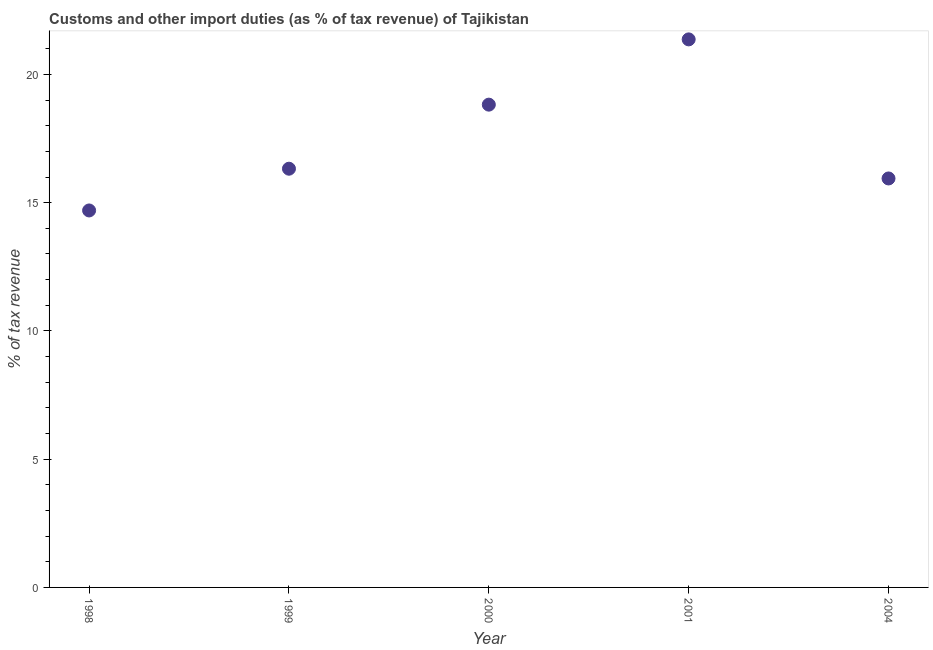What is the customs and other import duties in 2000?
Your answer should be compact. 18.82. Across all years, what is the maximum customs and other import duties?
Provide a short and direct response. 21.37. Across all years, what is the minimum customs and other import duties?
Your answer should be very brief. 14.7. In which year was the customs and other import duties maximum?
Your answer should be very brief. 2001. What is the sum of the customs and other import duties?
Your answer should be compact. 87.15. What is the difference between the customs and other import duties in 1999 and 2004?
Make the answer very short. 0.38. What is the average customs and other import duties per year?
Your answer should be very brief. 17.43. What is the median customs and other import duties?
Keep it short and to the point. 16.32. Do a majority of the years between 2001 and 2004 (inclusive) have customs and other import duties greater than 19 %?
Offer a very short reply. No. What is the ratio of the customs and other import duties in 1998 to that in 1999?
Offer a very short reply. 0.9. What is the difference between the highest and the second highest customs and other import duties?
Keep it short and to the point. 2.54. What is the difference between the highest and the lowest customs and other import duties?
Give a very brief answer. 6.67. How many dotlines are there?
Provide a short and direct response. 1. How many years are there in the graph?
Your answer should be compact. 5. Are the values on the major ticks of Y-axis written in scientific E-notation?
Keep it short and to the point. No. Does the graph contain grids?
Ensure brevity in your answer.  No. What is the title of the graph?
Your answer should be very brief. Customs and other import duties (as % of tax revenue) of Tajikistan. What is the label or title of the X-axis?
Offer a terse response. Year. What is the label or title of the Y-axis?
Give a very brief answer. % of tax revenue. What is the % of tax revenue in 1998?
Your response must be concise. 14.7. What is the % of tax revenue in 1999?
Give a very brief answer. 16.32. What is the % of tax revenue in 2000?
Offer a terse response. 18.82. What is the % of tax revenue in 2001?
Provide a short and direct response. 21.37. What is the % of tax revenue in 2004?
Offer a terse response. 15.94. What is the difference between the % of tax revenue in 1998 and 1999?
Make the answer very short. -1.63. What is the difference between the % of tax revenue in 1998 and 2000?
Your answer should be very brief. -4.13. What is the difference between the % of tax revenue in 1998 and 2001?
Provide a succinct answer. -6.67. What is the difference between the % of tax revenue in 1998 and 2004?
Make the answer very short. -1.25. What is the difference between the % of tax revenue in 1999 and 2000?
Your answer should be compact. -2.5. What is the difference between the % of tax revenue in 1999 and 2001?
Make the answer very short. -5.04. What is the difference between the % of tax revenue in 1999 and 2004?
Offer a very short reply. 0.38. What is the difference between the % of tax revenue in 2000 and 2001?
Keep it short and to the point. -2.54. What is the difference between the % of tax revenue in 2000 and 2004?
Your answer should be very brief. 2.88. What is the difference between the % of tax revenue in 2001 and 2004?
Ensure brevity in your answer.  5.42. What is the ratio of the % of tax revenue in 1998 to that in 2000?
Give a very brief answer. 0.78. What is the ratio of the % of tax revenue in 1998 to that in 2001?
Offer a terse response. 0.69. What is the ratio of the % of tax revenue in 1998 to that in 2004?
Your answer should be very brief. 0.92. What is the ratio of the % of tax revenue in 1999 to that in 2000?
Provide a succinct answer. 0.87. What is the ratio of the % of tax revenue in 1999 to that in 2001?
Offer a very short reply. 0.76. What is the ratio of the % of tax revenue in 1999 to that in 2004?
Make the answer very short. 1.02. What is the ratio of the % of tax revenue in 2000 to that in 2001?
Give a very brief answer. 0.88. What is the ratio of the % of tax revenue in 2000 to that in 2004?
Keep it short and to the point. 1.18. What is the ratio of the % of tax revenue in 2001 to that in 2004?
Give a very brief answer. 1.34. 